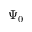Convert formula to latex. <formula><loc_0><loc_0><loc_500><loc_500>\Psi _ { 0 }</formula> 